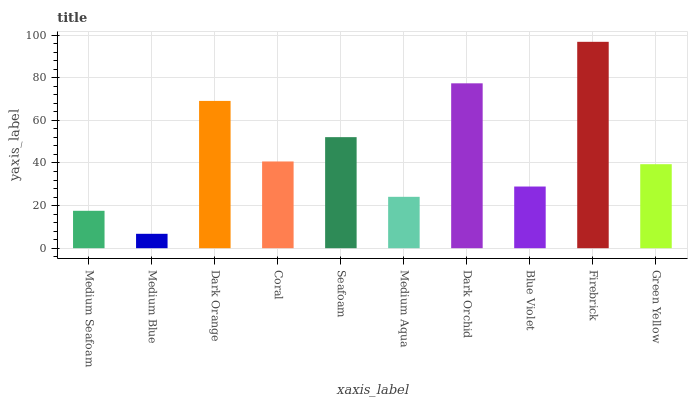Is Medium Blue the minimum?
Answer yes or no. Yes. Is Firebrick the maximum?
Answer yes or no. Yes. Is Dark Orange the minimum?
Answer yes or no. No. Is Dark Orange the maximum?
Answer yes or no. No. Is Dark Orange greater than Medium Blue?
Answer yes or no. Yes. Is Medium Blue less than Dark Orange?
Answer yes or no. Yes. Is Medium Blue greater than Dark Orange?
Answer yes or no. No. Is Dark Orange less than Medium Blue?
Answer yes or no. No. Is Coral the high median?
Answer yes or no. Yes. Is Green Yellow the low median?
Answer yes or no. Yes. Is Medium Aqua the high median?
Answer yes or no. No. Is Firebrick the low median?
Answer yes or no. No. 